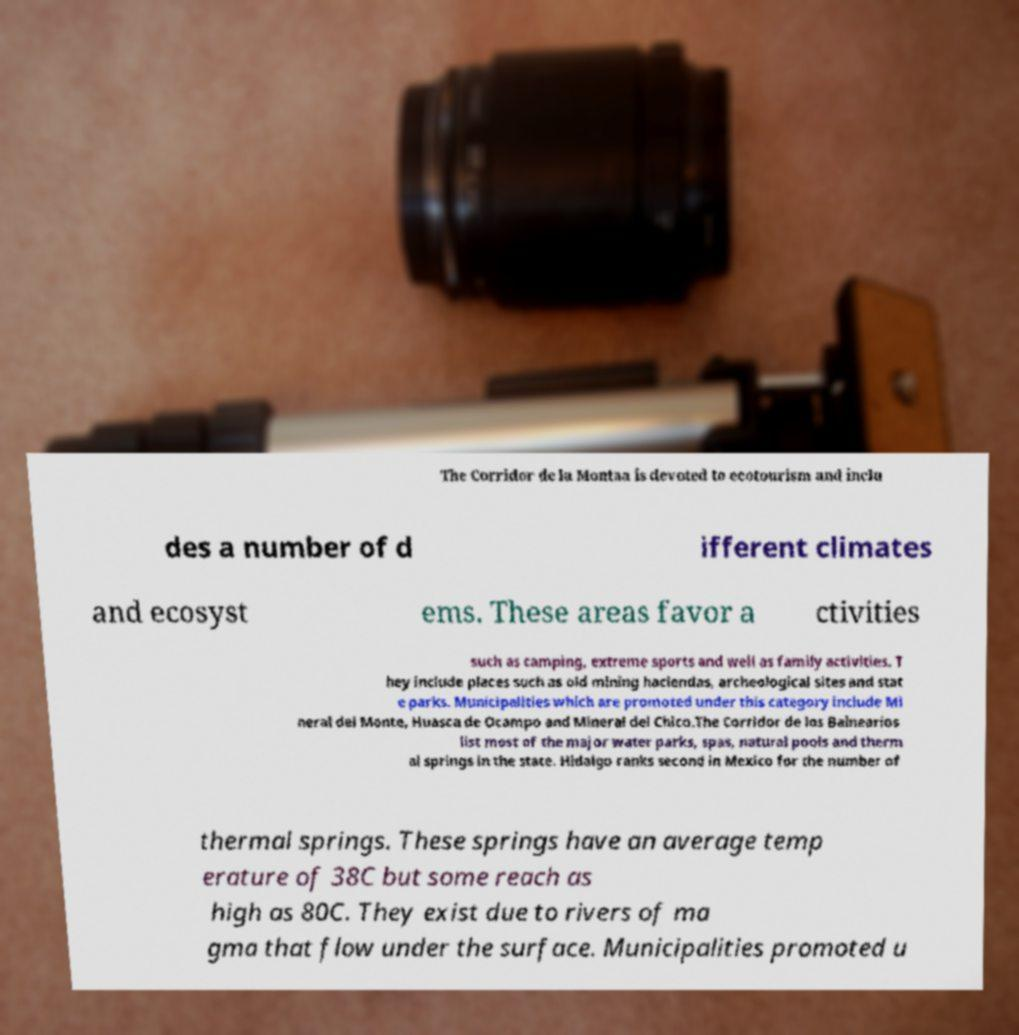What messages or text are displayed in this image? I need them in a readable, typed format. The Corridor de la Montaa is devoted to ecotourism and inclu des a number of d ifferent climates and ecosyst ems. These areas favor a ctivities such as camping, extreme sports and well as family activities. T hey include places such as old mining haciendas, archeological sites and stat e parks. Municipalities which are promoted under this category include Mi neral del Monte, Huasca de Ocampo and Mineral del Chico.The Corridor de los Balnearios list most of the major water parks, spas, natural pools and therm al springs in the state. Hidalgo ranks second in Mexico for the number of thermal springs. These springs have an average temp erature of 38C but some reach as high as 80C. They exist due to rivers of ma gma that flow under the surface. Municipalities promoted u 